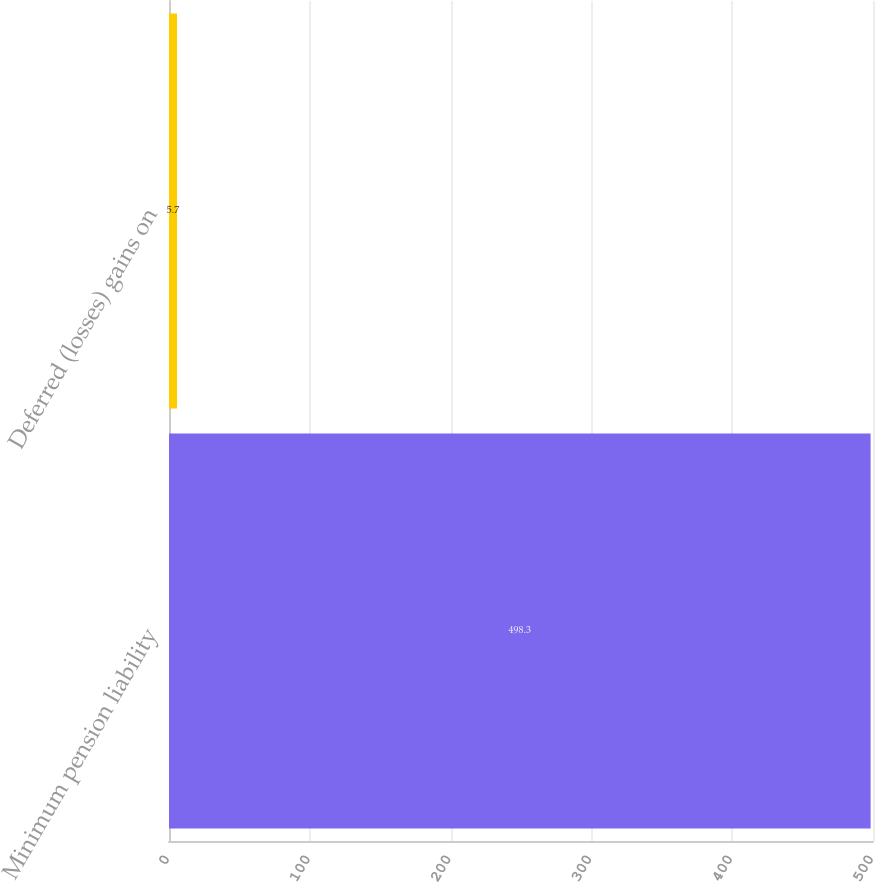Convert chart to OTSL. <chart><loc_0><loc_0><loc_500><loc_500><bar_chart><fcel>Minimum pension liability<fcel>Deferred (losses) gains on<nl><fcel>498.3<fcel>5.7<nl></chart> 